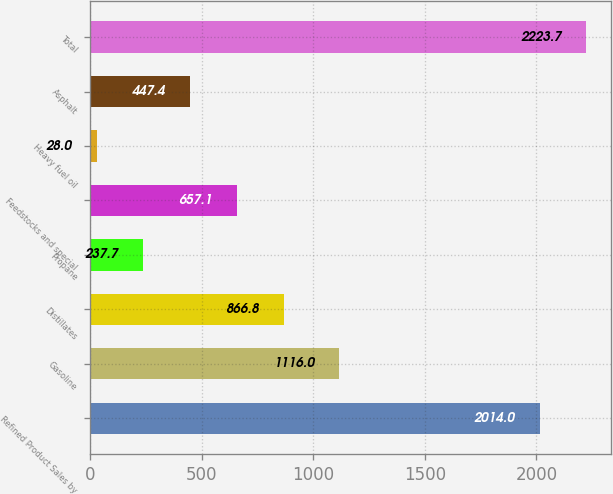Convert chart to OTSL. <chart><loc_0><loc_0><loc_500><loc_500><bar_chart><fcel>Refined Product Sales by<fcel>Gasoline<fcel>Distillates<fcel>Propane<fcel>Feedstocks and special<fcel>Heavy fuel oil<fcel>Asphalt<fcel>Total<nl><fcel>2014<fcel>1116<fcel>866.8<fcel>237.7<fcel>657.1<fcel>28<fcel>447.4<fcel>2223.7<nl></chart> 